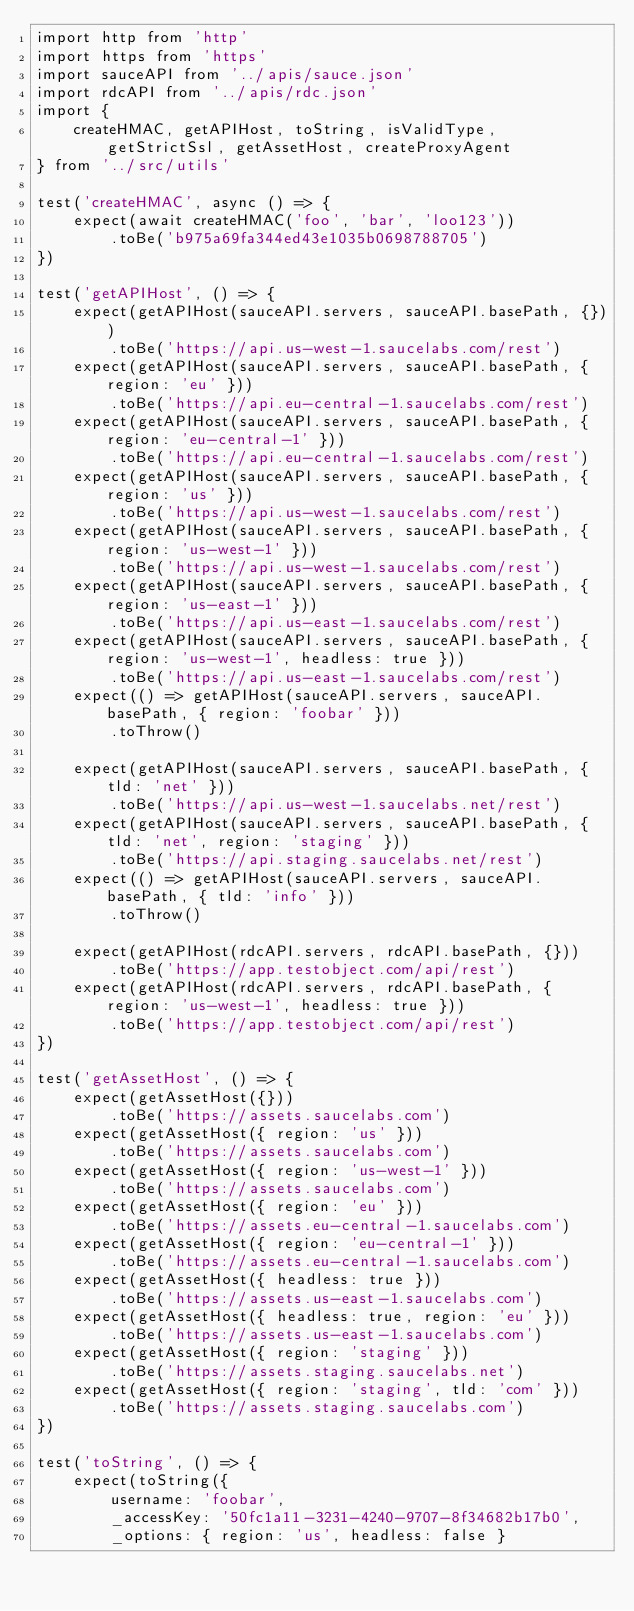<code> <loc_0><loc_0><loc_500><loc_500><_JavaScript_>import http from 'http'
import https from 'https'
import sauceAPI from '../apis/sauce.json'
import rdcAPI from '../apis/rdc.json'
import {
    createHMAC, getAPIHost, toString, isValidType, getStrictSsl, getAssetHost, createProxyAgent
} from '../src/utils'

test('createHMAC', async () => {
    expect(await createHMAC('foo', 'bar', 'loo123'))
        .toBe('b975a69fa344ed43e1035b0698788705')
})

test('getAPIHost', () => {
    expect(getAPIHost(sauceAPI.servers, sauceAPI.basePath, {}))
        .toBe('https://api.us-west-1.saucelabs.com/rest')
    expect(getAPIHost(sauceAPI.servers, sauceAPI.basePath, { region: 'eu' }))
        .toBe('https://api.eu-central-1.saucelabs.com/rest')
    expect(getAPIHost(sauceAPI.servers, sauceAPI.basePath, { region: 'eu-central-1' }))
        .toBe('https://api.eu-central-1.saucelabs.com/rest')
    expect(getAPIHost(sauceAPI.servers, sauceAPI.basePath, { region: 'us' }))
        .toBe('https://api.us-west-1.saucelabs.com/rest')
    expect(getAPIHost(sauceAPI.servers, sauceAPI.basePath, { region: 'us-west-1' }))
        .toBe('https://api.us-west-1.saucelabs.com/rest')
    expect(getAPIHost(sauceAPI.servers, sauceAPI.basePath, { region: 'us-east-1' }))
        .toBe('https://api.us-east-1.saucelabs.com/rest')
    expect(getAPIHost(sauceAPI.servers, sauceAPI.basePath, { region: 'us-west-1', headless: true }))
        .toBe('https://api.us-east-1.saucelabs.com/rest')
    expect(() => getAPIHost(sauceAPI.servers, sauceAPI.basePath, { region: 'foobar' }))
        .toThrow()

    expect(getAPIHost(sauceAPI.servers, sauceAPI.basePath, { tld: 'net' }))
        .toBe('https://api.us-west-1.saucelabs.net/rest')
    expect(getAPIHost(sauceAPI.servers, sauceAPI.basePath, { tld: 'net', region: 'staging' }))
        .toBe('https://api.staging.saucelabs.net/rest')
    expect(() => getAPIHost(sauceAPI.servers, sauceAPI.basePath, { tld: 'info' }))
        .toThrow()

    expect(getAPIHost(rdcAPI.servers, rdcAPI.basePath, {}))
        .toBe('https://app.testobject.com/api/rest')
    expect(getAPIHost(rdcAPI.servers, rdcAPI.basePath, { region: 'us-west-1', headless: true }))
        .toBe('https://app.testobject.com/api/rest')
})

test('getAssetHost', () => {
    expect(getAssetHost({}))
        .toBe('https://assets.saucelabs.com')
    expect(getAssetHost({ region: 'us' }))
        .toBe('https://assets.saucelabs.com')
    expect(getAssetHost({ region: 'us-west-1' }))
        .toBe('https://assets.saucelabs.com')
    expect(getAssetHost({ region: 'eu' }))
        .toBe('https://assets.eu-central-1.saucelabs.com')
    expect(getAssetHost({ region: 'eu-central-1' }))
        .toBe('https://assets.eu-central-1.saucelabs.com')
    expect(getAssetHost({ headless: true }))
        .toBe('https://assets.us-east-1.saucelabs.com')
    expect(getAssetHost({ headless: true, region: 'eu' }))
        .toBe('https://assets.us-east-1.saucelabs.com')
    expect(getAssetHost({ region: 'staging' }))
        .toBe('https://assets.staging.saucelabs.net')
    expect(getAssetHost({ region: 'staging', tld: 'com' }))
        .toBe('https://assets.staging.saucelabs.com')
})

test('toString', () => {
    expect(toString({
        username: 'foobar',
        _accessKey: '50fc1a11-3231-4240-9707-8f34682b17b0',
        _options: { region: 'us', headless: false }</code> 